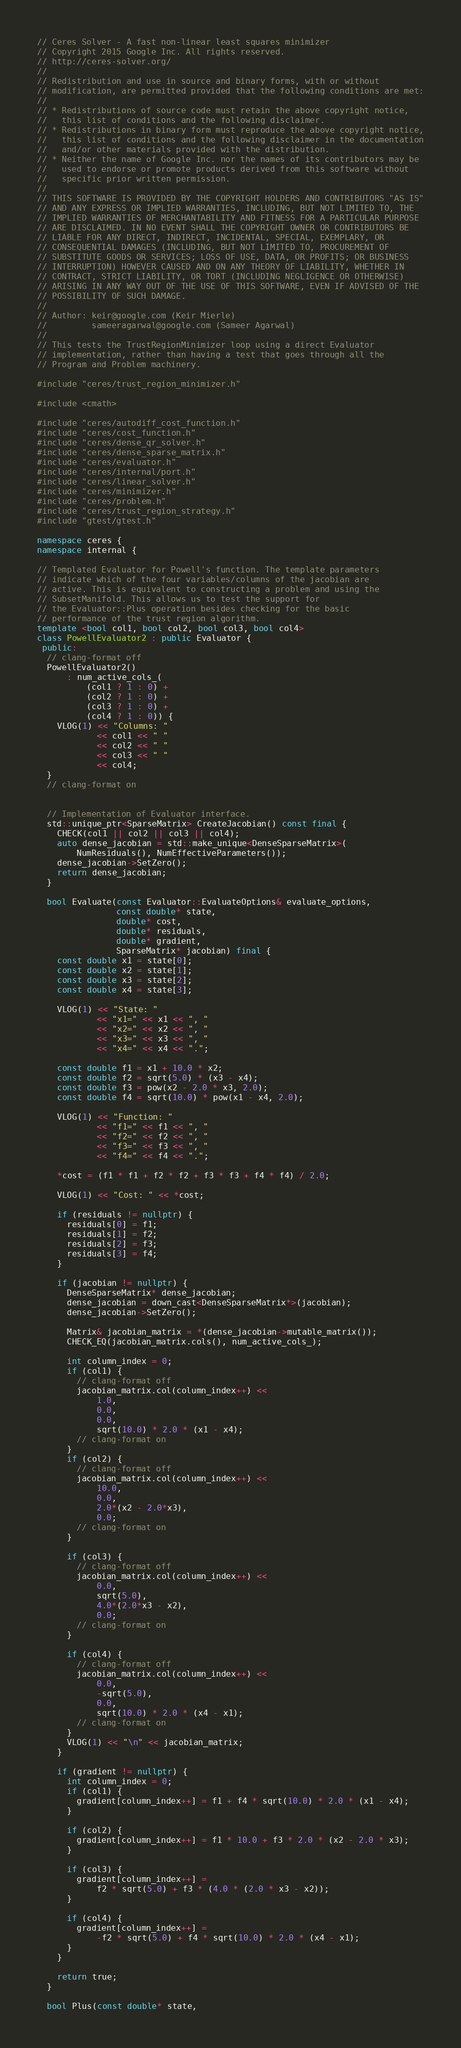Convert code to text. <code><loc_0><loc_0><loc_500><loc_500><_C++_>// Ceres Solver - A fast non-linear least squares minimizer
// Copyright 2015 Google Inc. All rights reserved.
// http://ceres-solver.org/
//
// Redistribution and use in source and binary forms, with or without
// modification, are permitted provided that the following conditions are met:
//
// * Redistributions of source code must retain the above copyright notice,
//   this list of conditions and the following disclaimer.
// * Redistributions in binary form must reproduce the above copyright notice,
//   this list of conditions and the following disclaimer in the documentation
//   and/or other materials provided with the distribution.
// * Neither the name of Google Inc. nor the names of its contributors may be
//   used to endorse or promote products derived from this software without
//   specific prior written permission.
//
// THIS SOFTWARE IS PROVIDED BY THE COPYRIGHT HOLDERS AND CONTRIBUTORS "AS IS"
// AND ANY EXPRESS OR IMPLIED WARRANTIES, INCLUDING, BUT NOT LIMITED TO, THE
// IMPLIED WARRANTIES OF MERCHANTABILITY AND FITNESS FOR A PARTICULAR PURPOSE
// ARE DISCLAIMED. IN NO EVENT SHALL THE COPYRIGHT OWNER OR CONTRIBUTORS BE
// LIABLE FOR ANY DIRECT, INDIRECT, INCIDENTAL, SPECIAL, EXEMPLARY, OR
// CONSEQUENTIAL DAMAGES (INCLUDING, BUT NOT LIMITED TO, PROCUREMENT OF
// SUBSTITUTE GOODS OR SERVICES; LOSS OF USE, DATA, OR PROFITS; OR BUSINESS
// INTERRUPTION) HOWEVER CAUSED AND ON ANY THEORY OF LIABILITY, WHETHER IN
// CONTRACT, STRICT LIABILITY, OR TORT (INCLUDING NEGLIGENCE OR OTHERWISE)
// ARISING IN ANY WAY OUT OF THE USE OF THIS SOFTWARE, EVEN IF ADVISED OF THE
// POSSIBILITY OF SUCH DAMAGE.
//
// Author: keir@google.com (Keir Mierle)
//         sameeragarwal@google.com (Sameer Agarwal)
//
// This tests the TrustRegionMinimizer loop using a direct Evaluator
// implementation, rather than having a test that goes through all the
// Program and Problem machinery.

#include "ceres/trust_region_minimizer.h"

#include <cmath>

#include "ceres/autodiff_cost_function.h"
#include "ceres/cost_function.h"
#include "ceres/dense_qr_solver.h"
#include "ceres/dense_sparse_matrix.h"
#include "ceres/evaluator.h"
#include "ceres/internal/port.h"
#include "ceres/linear_solver.h"
#include "ceres/minimizer.h"
#include "ceres/problem.h"
#include "ceres/trust_region_strategy.h"
#include "gtest/gtest.h"

namespace ceres {
namespace internal {

// Templated Evaluator for Powell's function. The template parameters
// indicate which of the four variables/columns of the jacobian are
// active. This is equivalent to constructing a problem and using the
// SubsetManifold. This allows us to test the support for
// the Evaluator::Plus operation besides checking for the basic
// performance of the trust region algorithm.
template <bool col1, bool col2, bool col3, bool col4>
class PowellEvaluator2 : public Evaluator {
 public:
  // clang-format off
  PowellEvaluator2()
      : num_active_cols_(
          (col1 ? 1 : 0) +
          (col2 ? 1 : 0) +
          (col3 ? 1 : 0) +
          (col4 ? 1 : 0)) {
    VLOG(1) << "Columns: "
            << col1 << " "
            << col2 << " "
            << col3 << " "
            << col4;
  }
  // clang-format on


  // Implementation of Evaluator interface.
  std::unique_ptr<SparseMatrix> CreateJacobian() const final {
    CHECK(col1 || col2 || col3 || col4);
    auto dense_jacobian = std::make_unique<DenseSparseMatrix>(
        NumResiduals(), NumEffectiveParameters());
    dense_jacobian->SetZero();
    return dense_jacobian;
  }

  bool Evaluate(const Evaluator::EvaluateOptions& evaluate_options,
                const double* state,
                double* cost,
                double* residuals,
                double* gradient,
                SparseMatrix* jacobian) final {
    const double x1 = state[0];
    const double x2 = state[1];
    const double x3 = state[2];
    const double x4 = state[3];

    VLOG(1) << "State: "
            << "x1=" << x1 << ", "
            << "x2=" << x2 << ", "
            << "x3=" << x3 << ", "
            << "x4=" << x4 << ".";

    const double f1 = x1 + 10.0 * x2;
    const double f2 = sqrt(5.0) * (x3 - x4);
    const double f3 = pow(x2 - 2.0 * x3, 2.0);
    const double f4 = sqrt(10.0) * pow(x1 - x4, 2.0);

    VLOG(1) << "Function: "
            << "f1=" << f1 << ", "
            << "f2=" << f2 << ", "
            << "f3=" << f3 << ", "
            << "f4=" << f4 << ".";

    *cost = (f1 * f1 + f2 * f2 + f3 * f3 + f4 * f4) / 2.0;

    VLOG(1) << "Cost: " << *cost;

    if (residuals != nullptr) {
      residuals[0] = f1;
      residuals[1] = f2;
      residuals[2] = f3;
      residuals[3] = f4;
    }

    if (jacobian != nullptr) {
      DenseSparseMatrix* dense_jacobian;
      dense_jacobian = down_cast<DenseSparseMatrix*>(jacobian);
      dense_jacobian->SetZero();

      Matrix& jacobian_matrix = *(dense_jacobian->mutable_matrix());
      CHECK_EQ(jacobian_matrix.cols(), num_active_cols_);

      int column_index = 0;
      if (col1) {
        // clang-format off
        jacobian_matrix.col(column_index++) <<
            1.0,
            0.0,
            0.0,
            sqrt(10.0) * 2.0 * (x1 - x4);
        // clang-format on
      }
      if (col2) {
        // clang-format off
        jacobian_matrix.col(column_index++) <<
            10.0,
            0.0,
            2.0*(x2 - 2.0*x3),
            0.0;
        // clang-format on
      }

      if (col3) {
        // clang-format off
        jacobian_matrix.col(column_index++) <<
            0.0,
            sqrt(5.0),
            4.0*(2.0*x3 - x2),
            0.0;
        // clang-format on
      }

      if (col4) {
        // clang-format off
        jacobian_matrix.col(column_index++) <<
            0.0,
            -sqrt(5.0),
            0.0,
            sqrt(10.0) * 2.0 * (x4 - x1);
        // clang-format on
      }
      VLOG(1) << "\n" << jacobian_matrix;
    }

    if (gradient != nullptr) {
      int column_index = 0;
      if (col1) {
        gradient[column_index++] = f1 + f4 * sqrt(10.0) * 2.0 * (x1 - x4);
      }

      if (col2) {
        gradient[column_index++] = f1 * 10.0 + f3 * 2.0 * (x2 - 2.0 * x3);
      }

      if (col3) {
        gradient[column_index++] =
            f2 * sqrt(5.0) + f3 * (4.0 * (2.0 * x3 - x2));
      }

      if (col4) {
        gradient[column_index++] =
            -f2 * sqrt(5.0) + f4 * sqrt(10.0) * 2.0 * (x4 - x1);
      }
    }

    return true;
  }

  bool Plus(const double* state,</code> 